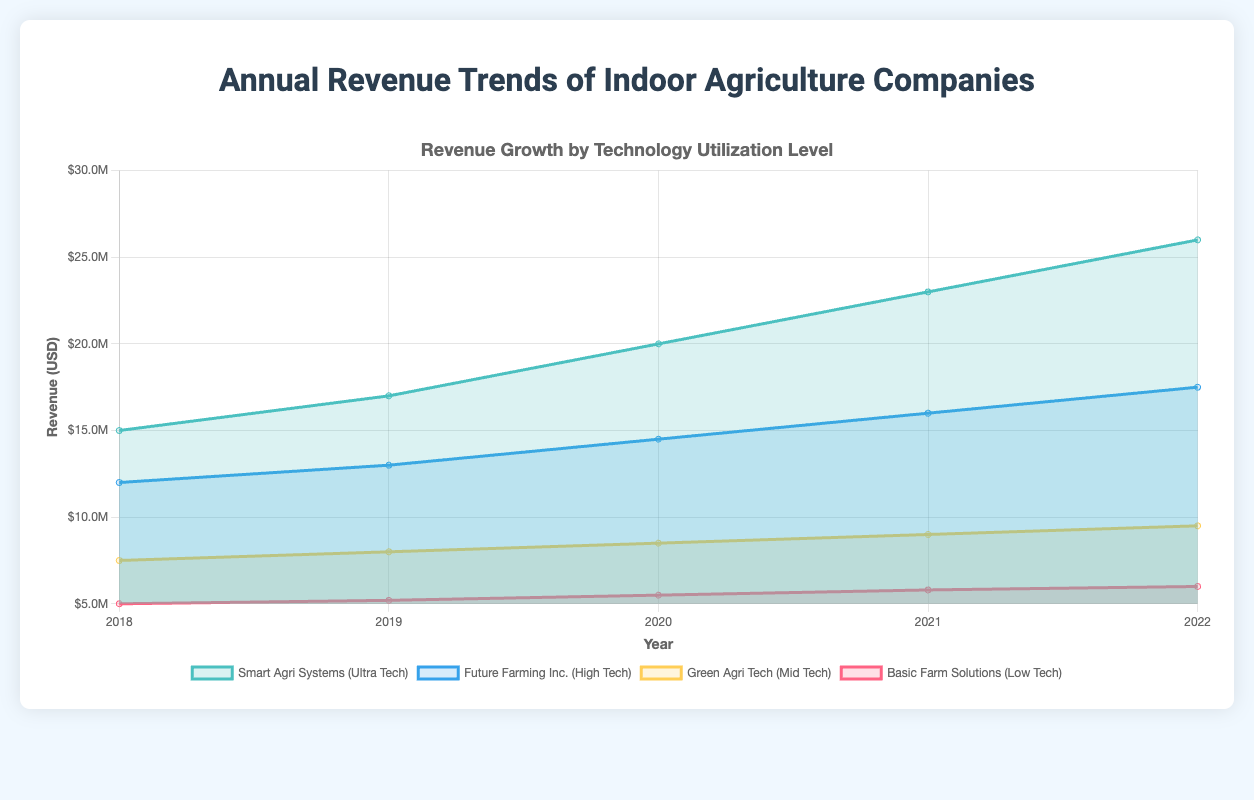what is the year with the highest revenue for Smart Agri Systems (Ultra Tech)? The revenue for Smart Agri Systems (Ultra Tech) is highest in 2022, which is shown as the topmost value on the chart for the corresponding dataset
Answer: 2022 How does the revenue for Future Farming Inc. (High Tech) in 2020 compare to the revenue for Green Agri Tech (Mid Tech) in the same year? In 2020, the revenue for Future Farming Inc. (High Tech) was $14,500,000, while the revenue for Green Agri Tech (Mid Tech) was $8,500,000, indicating that Future Farming Inc. had significantly higher revenue
Answer: Future Farming Inc. had higher revenue Which company had the least growth in revenue from 2018 to 2022? To identify the company with the least growth, we look at the difference in revenue between 2018 and 2022 for each company. Basic Farm Solutions (Low Tech) increased from $5,000,000 to $6,000,000, which is a smaller increase compared to the other companies
Answer: Basic Farm Solutions (Low Tech) What is the overall trend observed for Smart Agri Systems (Ultra Tech)? The trend for Smart Agri Systems (Ultra Tech) shows a steady increase in revenue from $15,000,000 in 2018 to $26,000,000 in 2022, indicating continual growth each year
Answer: Steady increase What was the total revenue for all companies in 2019? To calculate the total revenue, sum the revenues for each company in 2019: $5,200,000 (Low Tech) + $8,000,000 (Mid Tech) + $13,000,000 (High Tech) + $17,000,000 (Ultra Tech) = $43,200,000
Answer: $43,200,000 How did the revenue for Basic Farm Solutions (Low Tech) change from 2020 to 2021? The revenue for Basic Farm Solutions (Low Tech) increased from $5,500,000 in 2020 to $5,800,000 in 2021, showing an increase of $300,000
Answer: Increased by $300,000 Between which years did Future Farming Inc. (High Tech) experience the largest revenue increase? By looking at the differences in revenue between years for Future Farming Inc. (High Tech), the largest increase occurred between 2019 ($13,000,000) and 2020 ($14,500,000), where it increased by $1,500,000
Answer: 2019 to 2020 Which technology level consistently had the second highest revenue each year? By observing the chart for each year, Future Farming Inc. (High Tech) consistently had the second highest revenue after Smart Agri Systems (Ultra Tech)
Answer: High Tech What was the average revenue for Green Agri Tech (Mid Tech) over the years? To find the average revenue, sum the revenues for Green Agri Tech from 2018 to 2022 and then divide by the number of years: (7,500,000 + 8,000,000 + 8,500,000 + 9,000,000 + 9,500,000) / 5 = $8,500,000
Answer: $8,500,000 